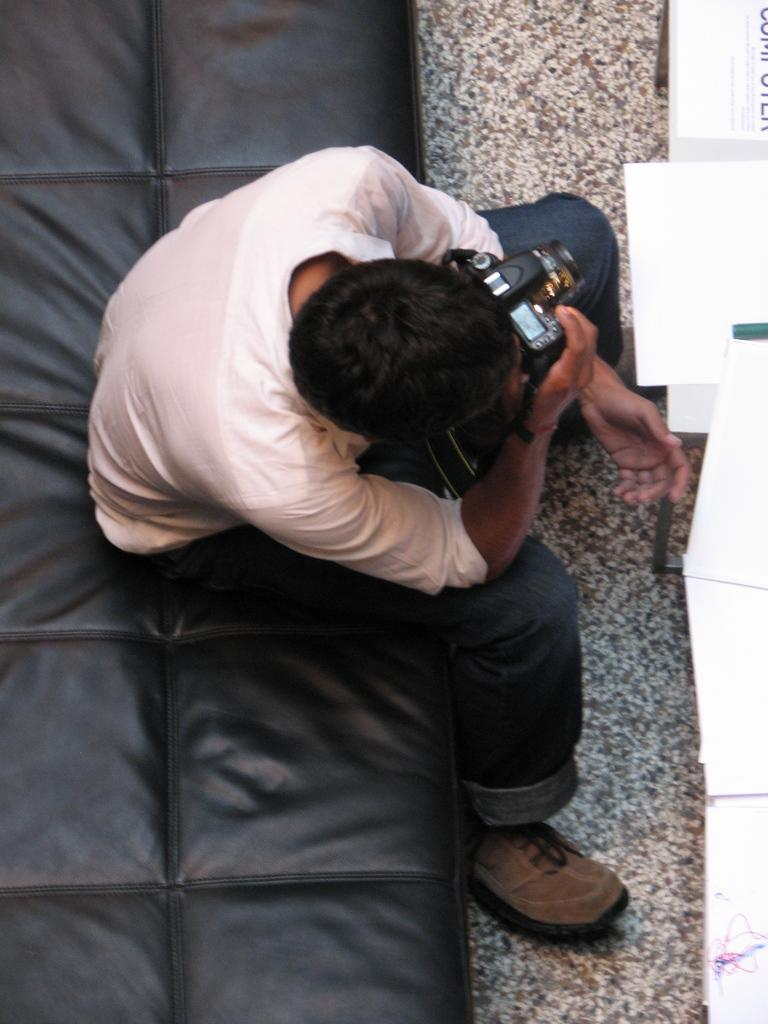Who is in the image? There is a man in the image. What is the man doing in the image? The man is sitting on a sofa. What is the man holding in his hands? The man is holding a camera in his hands. What is in front of the man? There is a table in front of the man. What is on the table? Papers are present on the table. What type of plough is the man using to compare his elbows in the image? There is no plough present in the image, and the man is not using any object to compare his elbows. 